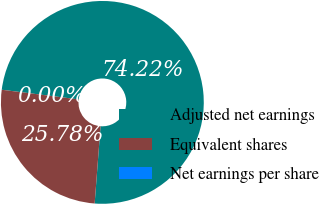Convert chart. <chart><loc_0><loc_0><loc_500><loc_500><pie_chart><fcel>Adjusted net earnings<fcel>Equivalent shares<fcel>Net earnings per share<nl><fcel>74.22%<fcel>25.78%<fcel>0.0%<nl></chart> 